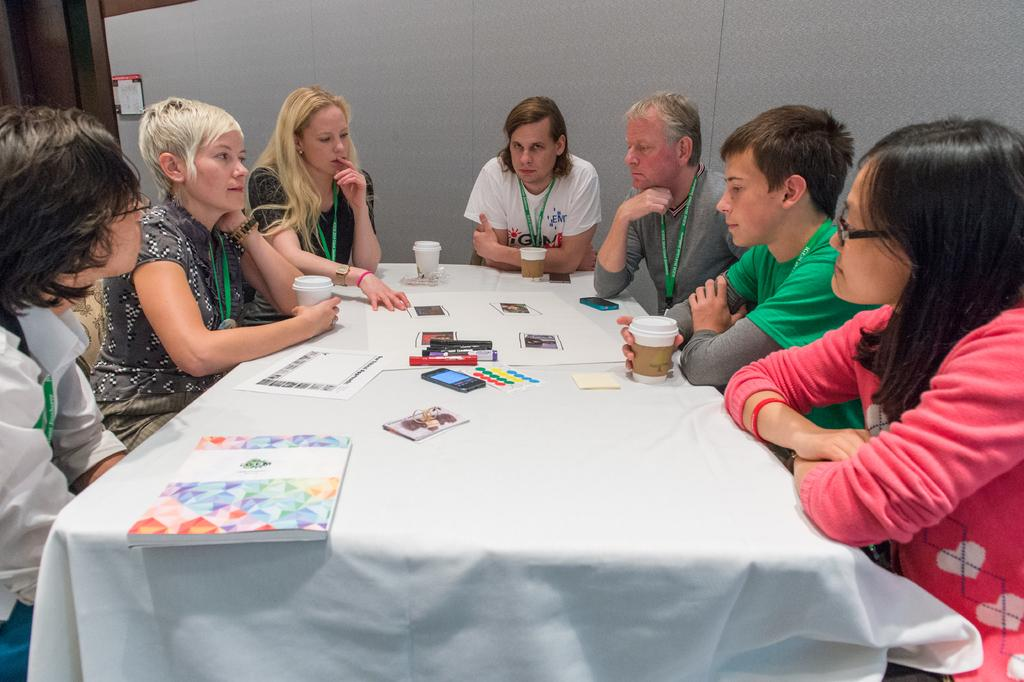What is present on the table in the image? A white cloth is on the table in the image. How many people are in the image? There are 3 men and 4 women in the image, making a total of 7 people. What are some of the people holding in the image? Some of the people are holding coffee mugs. What can be seen in the background of the image? There is a white wall in the background, and there is a frame on the wall. What type of stitch is being used to hold the frame together in the image? There is no frame being held together by stitching in the image; the frame is already assembled and mounted on the wall. What type of quartz is visible on the table in the image? There is no quartz present on the table in the image. 